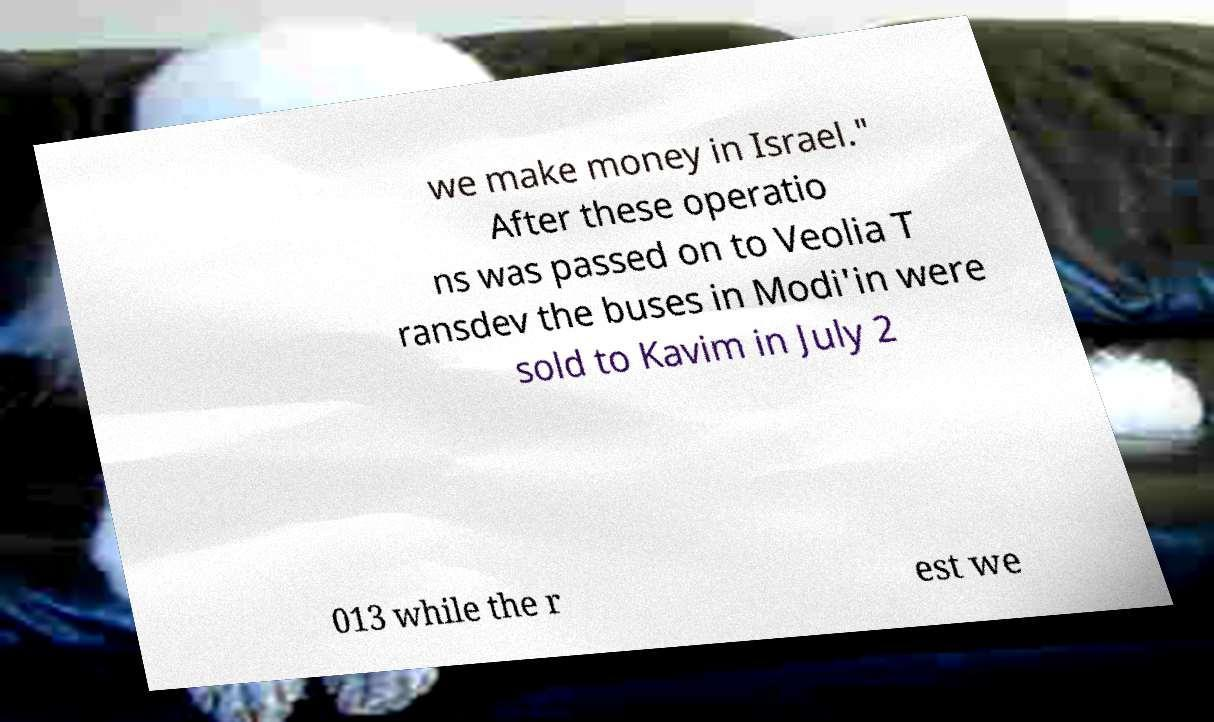What messages or text are displayed in this image? I need them in a readable, typed format. we make money in Israel." After these operatio ns was passed on to Veolia T ransdev the buses in Modi'in were sold to Kavim in July 2 013 while the r est we 